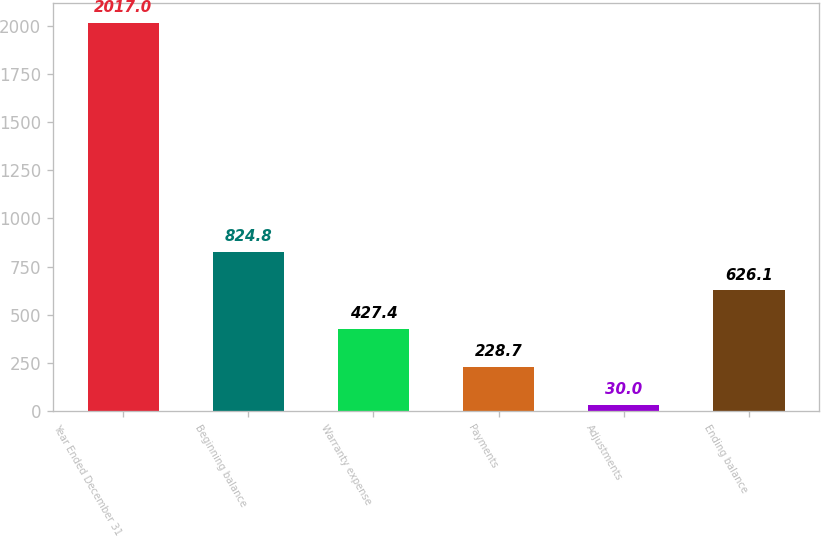Convert chart. <chart><loc_0><loc_0><loc_500><loc_500><bar_chart><fcel>Year Ended December 31<fcel>Beginning balance<fcel>Warranty expense<fcel>Payments<fcel>Adjustments<fcel>Ending balance<nl><fcel>2017<fcel>824.8<fcel>427.4<fcel>228.7<fcel>30<fcel>626.1<nl></chart> 